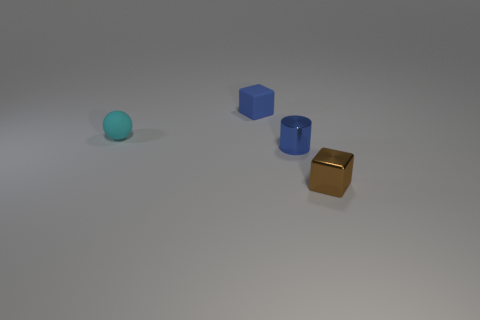What materials do these objects look like they are made from? The objects appear to be made of a matte plastic material, each with a different color, which gives a simple yet visually appealing aesthetic, potentially for educational or sorting activities. 